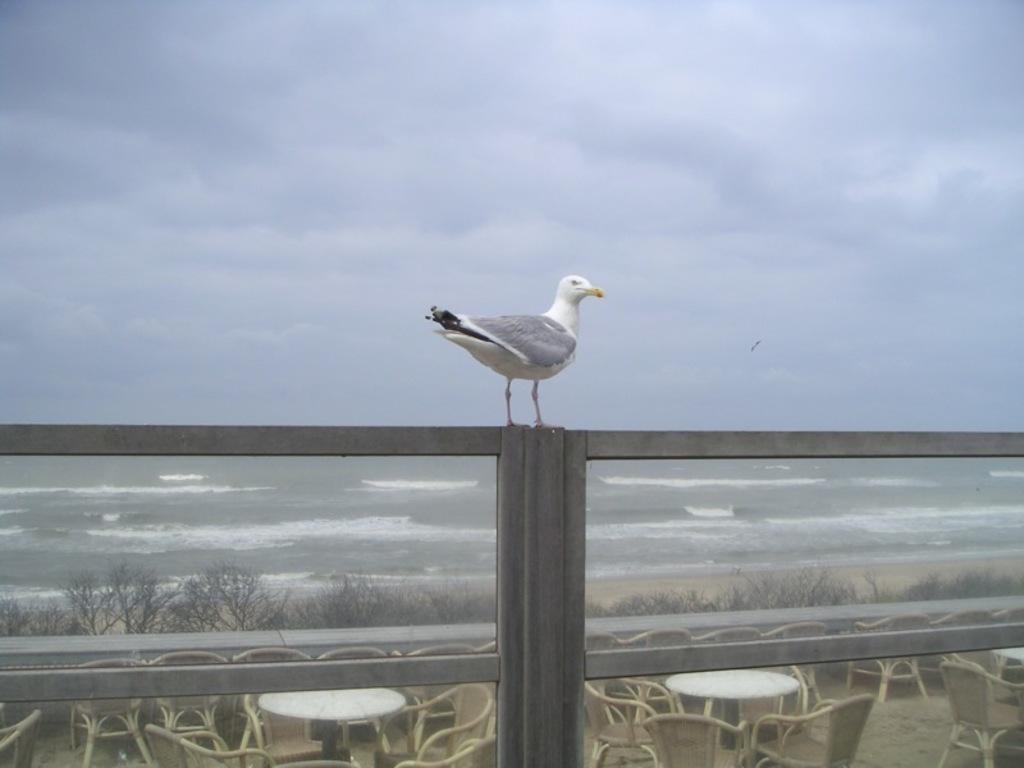Could you give a brief overview of what you see in this image? In this image we can see a bird on a fence. On the bottom of the image we can see some tables and a group of chairs on the floor. We can also see some plants. On the backside we can see a large water body and the sky which looks cloudy. 